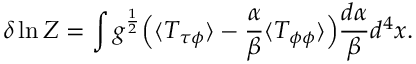<formula> <loc_0><loc_0><loc_500><loc_500>\delta \ln Z = \int g ^ { \frac { 1 } { 2 } } \left ( \langle T _ { \tau \phi } \rangle - { \frac { \alpha } { \beta } } \langle T _ { \phi \phi } \rangle \right ) { \frac { d \alpha } { \beta } } d ^ { 4 } x .</formula> 